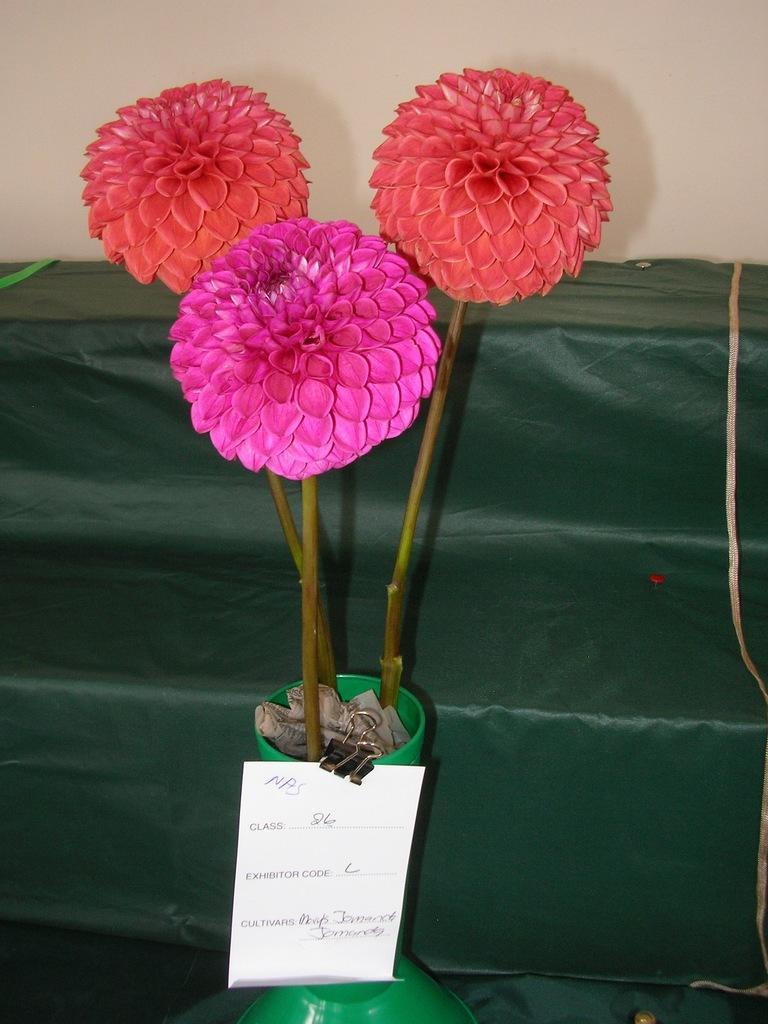Describe this image in one or two sentences. In this image there are three colorful flowers. There is a paper on the pot. There is a green color sofa on the backside and a cream color wall. 